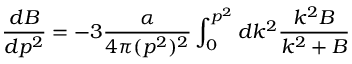<formula> <loc_0><loc_0><loc_500><loc_500>{ \frac { d B } { d p ^ { 2 } } } = - 3 { \frac { \alpha } { 4 \pi ( p ^ { 2 } ) ^ { 2 } } } \int _ { 0 } ^ { p ^ { 2 } } d k ^ { 2 } { \frac { k ^ { 2 } B } { k ^ { 2 } + B } }</formula> 